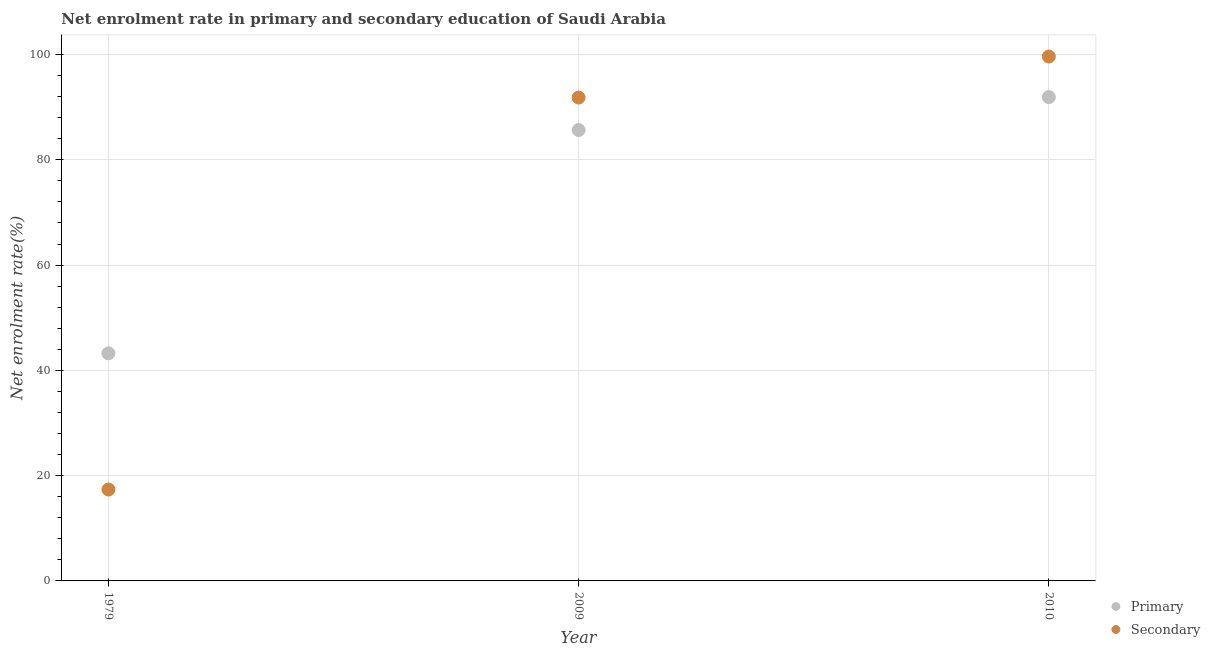Is the number of dotlines equal to the number of legend labels?
Provide a succinct answer. Yes. What is the enrollment rate in primary education in 1979?
Keep it short and to the point. 43.24. Across all years, what is the maximum enrollment rate in primary education?
Offer a very short reply. 91.91. Across all years, what is the minimum enrollment rate in secondary education?
Offer a terse response. 17.37. In which year was the enrollment rate in primary education minimum?
Provide a succinct answer. 1979. What is the total enrollment rate in secondary education in the graph?
Make the answer very short. 208.82. What is the difference between the enrollment rate in secondary education in 2009 and that in 2010?
Keep it short and to the point. -7.79. What is the difference between the enrollment rate in secondary education in 2010 and the enrollment rate in primary education in 2009?
Keep it short and to the point. 13.96. What is the average enrollment rate in primary education per year?
Provide a short and direct response. 73.6. In the year 1979, what is the difference between the enrollment rate in secondary education and enrollment rate in primary education?
Provide a short and direct response. -25.87. In how many years, is the enrollment rate in primary education greater than 64 %?
Keep it short and to the point. 2. What is the ratio of the enrollment rate in primary education in 1979 to that in 2009?
Your response must be concise. 0.5. What is the difference between the highest and the second highest enrollment rate in secondary education?
Your answer should be very brief. 7.79. What is the difference between the highest and the lowest enrollment rate in primary education?
Offer a terse response. 48.67. Is the enrollment rate in secondary education strictly greater than the enrollment rate in primary education over the years?
Provide a short and direct response. No. Is the enrollment rate in secondary education strictly less than the enrollment rate in primary education over the years?
Ensure brevity in your answer.  No. How many years are there in the graph?
Your response must be concise. 3. What is the title of the graph?
Your response must be concise. Net enrolment rate in primary and secondary education of Saudi Arabia. Does "Services" appear as one of the legend labels in the graph?
Make the answer very short. No. What is the label or title of the Y-axis?
Ensure brevity in your answer.  Net enrolment rate(%). What is the Net enrolment rate(%) of Primary in 1979?
Your response must be concise. 43.24. What is the Net enrolment rate(%) in Secondary in 1979?
Offer a very short reply. 17.37. What is the Net enrolment rate(%) in Primary in 2009?
Offer a very short reply. 85.67. What is the Net enrolment rate(%) in Secondary in 2009?
Ensure brevity in your answer.  91.83. What is the Net enrolment rate(%) in Primary in 2010?
Offer a very short reply. 91.91. What is the Net enrolment rate(%) in Secondary in 2010?
Your response must be concise. 99.62. Across all years, what is the maximum Net enrolment rate(%) of Primary?
Offer a very short reply. 91.91. Across all years, what is the maximum Net enrolment rate(%) of Secondary?
Provide a short and direct response. 99.62. Across all years, what is the minimum Net enrolment rate(%) of Primary?
Offer a very short reply. 43.24. Across all years, what is the minimum Net enrolment rate(%) in Secondary?
Offer a terse response. 17.37. What is the total Net enrolment rate(%) of Primary in the graph?
Offer a terse response. 220.81. What is the total Net enrolment rate(%) of Secondary in the graph?
Your response must be concise. 208.82. What is the difference between the Net enrolment rate(%) of Primary in 1979 and that in 2009?
Your response must be concise. -42.43. What is the difference between the Net enrolment rate(%) of Secondary in 1979 and that in 2009?
Keep it short and to the point. -74.46. What is the difference between the Net enrolment rate(%) of Primary in 1979 and that in 2010?
Offer a terse response. -48.67. What is the difference between the Net enrolment rate(%) in Secondary in 1979 and that in 2010?
Provide a succinct answer. -82.26. What is the difference between the Net enrolment rate(%) in Primary in 2009 and that in 2010?
Your response must be concise. -6.24. What is the difference between the Net enrolment rate(%) of Secondary in 2009 and that in 2010?
Ensure brevity in your answer.  -7.79. What is the difference between the Net enrolment rate(%) of Primary in 1979 and the Net enrolment rate(%) of Secondary in 2009?
Give a very brief answer. -48.59. What is the difference between the Net enrolment rate(%) in Primary in 1979 and the Net enrolment rate(%) in Secondary in 2010?
Provide a succinct answer. -56.39. What is the difference between the Net enrolment rate(%) in Primary in 2009 and the Net enrolment rate(%) in Secondary in 2010?
Offer a very short reply. -13.96. What is the average Net enrolment rate(%) of Primary per year?
Your answer should be compact. 73.6. What is the average Net enrolment rate(%) in Secondary per year?
Offer a very short reply. 69.61. In the year 1979, what is the difference between the Net enrolment rate(%) in Primary and Net enrolment rate(%) in Secondary?
Ensure brevity in your answer.  25.87. In the year 2009, what is the difference between the Net enrolment rate(%) of Primary and Net enrolment rate(%) of Secondary?
Provide a short and direct response. -6.16. In the year 2010, what is the difference between the Net enrolment rate(%) of Primary and Net enrolment rate(%) of Secondary?
Provide a succinct answer. -7.71. What is the ratio of the Net enrolment rate(%) of Primary in 1979 to that in 2009?
Your answer should be very brief. 0.5. What is the ratio of the Net enrolment rate(%) in Secondary in 1979 to that in 2009?
Provide a succinct answer. 0.19. What is the ratio of the Net enrolment rate(%) in Primary in 1979 to that in 2010?
Provide a succinct answer. 0.47. What is the ratio of the Net enrolment rate(%) in Secondary in 1979 to that in 2010?
Keep it short and to the point. 0.17. What is the ratio of the Net enrolment rate(%) in Primary in 2009 to that in 2010?
Provide a short and direct response. 0.93. What is the ratio of the Net enrolment rate(%) in Secondary in 2009 to that in 2010?
Make the answer very short. 0.92. What is the difference between the highest and the second highest Net enrolment rate(%) in Primary?
Keep it short and to the point. 6.24. What is the difference between the highest and the second highest Net enrolment rate(%) of Secondary?
Your answer should be compact. 7.79. What is the difference between the highest and the lowest Net enrolment rate(%) in Primary?
Your response must be concise. 48.67. What is the difference between the highest and the lowest Net enrolment rate(%) in Secondary?
Offer a very short reply. 82.26. 